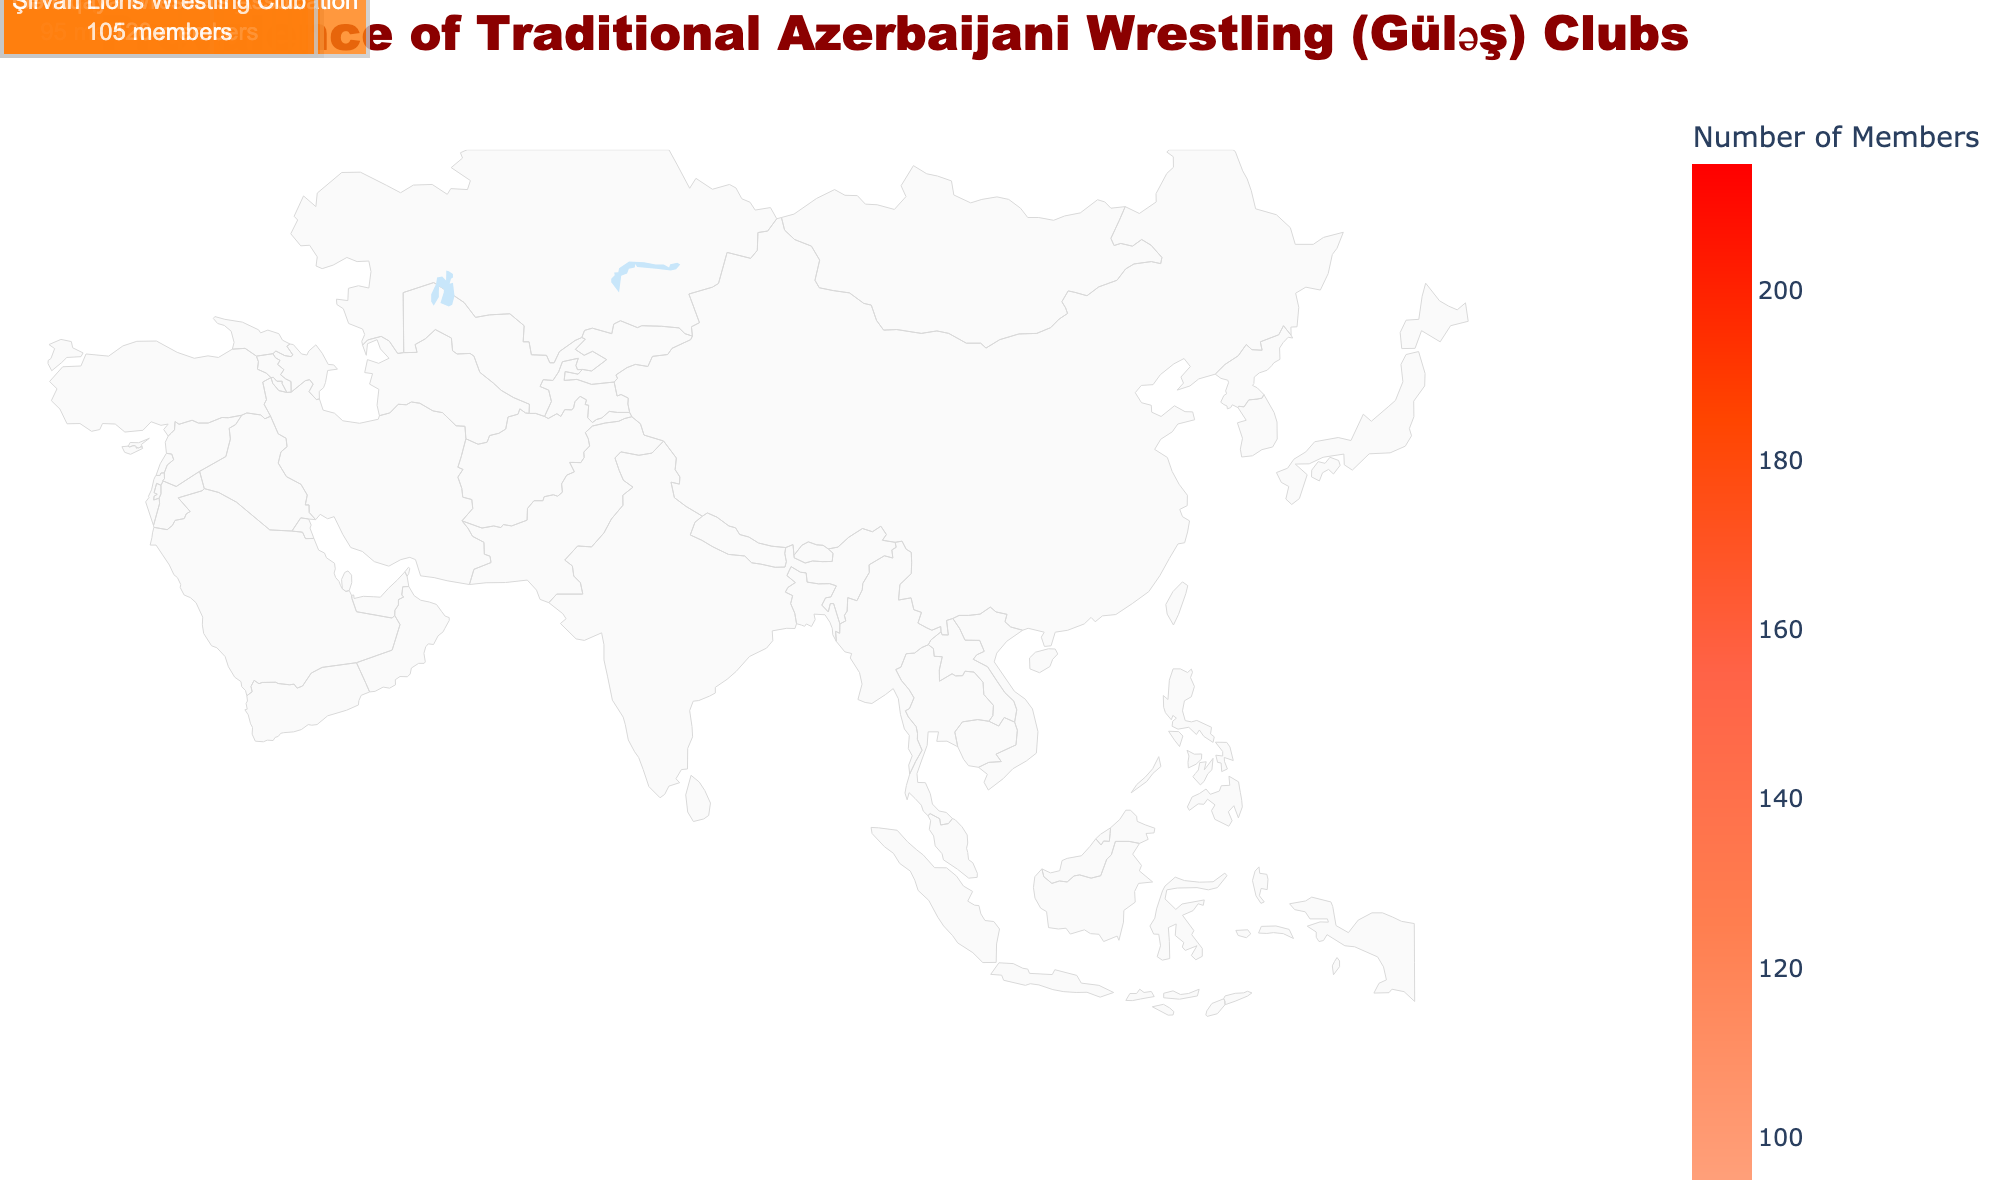How many members does the Neftchi Güləş Club in Baku have? The number of members is indicated directly in the figure under the annotation for Baku. It’s labeled as "215 members".
Answer: 215 Which region has the highest number of club members? To determine this, look for the region with the largest numerical annotation. Baku, with 215 members, has the highest number.
Answer: Baku What's the average number of members across all the Güləş clubs? Sum all the members from each club and divide by the number of clubs. The total is 215 + 180 + 145 + 130 + 160 + 110 + 190 + 95 + 120 + 105 = 1350. There are 10 clubs, so the average is 1350 / 10 = 135.
Answer: 135 Which two regions have the closest numbers of members, and what are those numbers? Compare the numerical annotations to find the closest pair. Shirvan (105) and Guba-Khachmaz (110) have a difference of 5 members.
Answer: Shirvan: 105, Guba-Khachmaz: 110 What is the sum of the members in the cities of Ganja and Lankaran? Add the members of the two cities: Ganja (180) and Lankaran (130). The sum is 180 + 130 = 310.
Answer: 310 Which Güləş Club has the fewest members and in which region is it located? Look for the smallest number in the annotations. The Qarabağ Warriors in Upper Karabakh have the fewest members with 95.
Answer: Qarabağ Warriors, Upper Karabakh How many more members does the Sumqayıt Steel Güləş Club have compared to the Şirvan Lions Wrestling Club? Subtract the members of the Şirvan Lions (105) from the Sumqayıt Steel (190). The difference is 190 - 105 = 85.
Answer: 85 Rank the clubs from highest to lowest based on the number of members. List the clubs and their members in descending order: Neftchi (215), Sumqayıt Steel (190), Kəpəz (180), Kür Olympians (160), Silk Road (145), Xəzər Maritime (130), Gəmiqaya (120), Şahdağ Mountain (110), Şirvan Lions (105), Qarabağ Warriors (95).
Answer: Neftchi > Sumqayıt Steel > Kəpəz > Kür Olympians > Silk Road > Xəzər Maritime > Gəmiqaya > Şahdağ Mountain > Şirvan Lions > Qarabağ Warriors Which city has a club located in the Sheki-Zagatala region, and how many members are there? Look for the annotation in the Sheki-Zagatala region. The Silk Road Güləş Center is located in Sheki with 145 members.
Answer: Sheki, 145 What's the total number of Güləş clubs mentioned in the figure? Count the unique annotations of the clubs. There are 10 clubs listed.
Answer: 10 